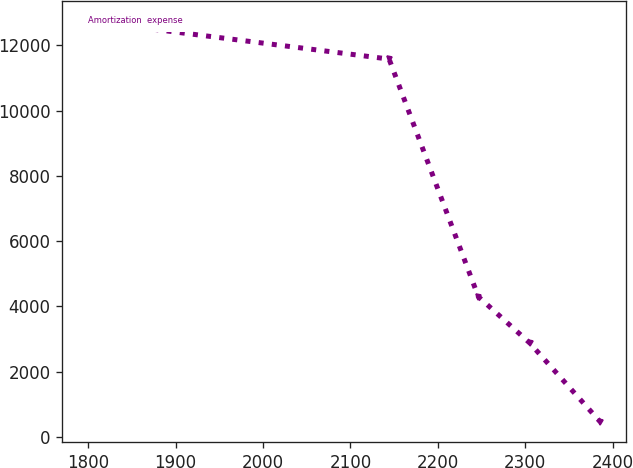Convert chart to OTSL. <chart><loc_0><loc_0><loc_500><loc_500><line_chart><ecel><fcel>Amortization  expense<nl><fcel>1799.47<fcel>12749.6<nl><fcel>2144.22<fcel>11580.9<nl><fcel>2246.33<fcel>4299.5<nl><fcel>2304.98<fcel>2884.6<nl><fcel>2385.97<fcel>459.13<nl></chart> 